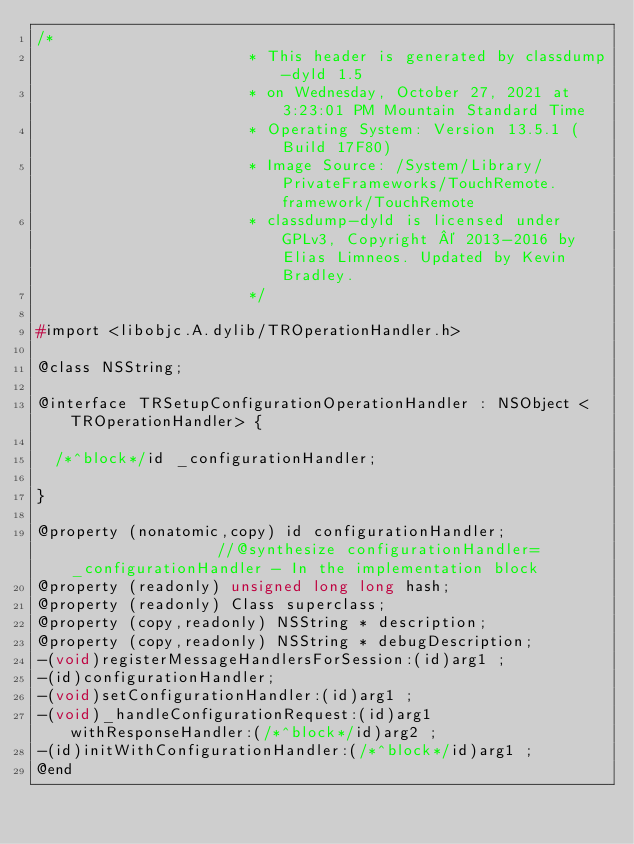Convert code to text. <code><loc_0><loc_0><loc_500><loc_500><_C_>/*
                       * This header is generated by classdump-dyld 1.5
                       * on Wednesday, October 27, 2021 at 3:23:01 PM Mountain Standard Time
                       * Operating System: Version 13.5.1 (Build 17F80)
                       * Image Source: /System/Library/PrivateFrameworks/TouchRemote.framework/TouchRemote
                       * classdump-dyld is licensed under GPLv3, Copyright © 2013-2016 by Elias Limneos. Updated by Kevin Bradley.
                       */

#import <libobjc.A.dylib/TROperationHandler.h>

@class NSString;

@interface TRSetupConfigurationOperationHandler : NSObject <TROperationHandler> {

	/*^block*/id _configurationHandler;

}

@property (nonatomic,copy) id configurationHandler;                 //@synthesize configurationHandler=_configurationHandler - In the implementation block
@property (readonly) unsigned long long hash; 
@property (readonly) Class superclass; 
@property (copy,readonly) NSString * description; 
@property (copy,readonly) NSString * debugDescription; 
-(void)registerMessageHandlersForSession:(id)arg1 ;
-(id)configurationHandler;
-(void)setConfigurationHandler:(id)arg1 ;
-(void)_handleConfigurationRequest:(id)arg1 withResponseHandler:(/*^block*/id)arg2 ;
-(id)initWithConfigurationHandler:(/*^block*/id)arg1 ;
@end

</code> 